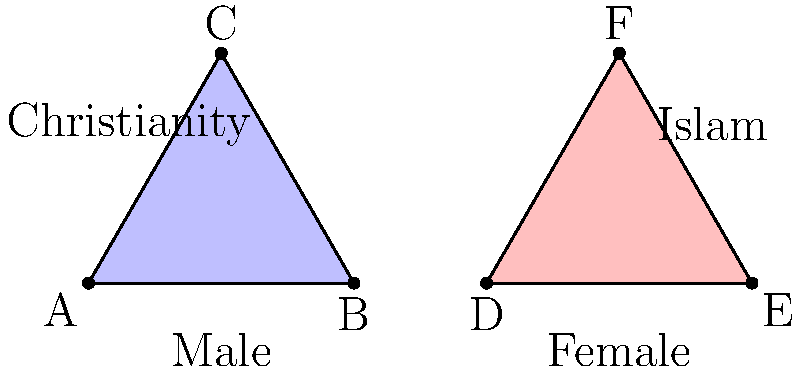In the diagram, two equilateral triangles represent the male and female populations in Christianity and Islam. If the area of each triangle is 12 square units, what is the area of the region where the triangles overlap, representing individuals who identify with both genders or faiths? To solve this problem, we need to follow these steps:

1) First, we need to calculate the side length of each equilateral triangle. The area of an equilateral triangle is given by the formula:

   $A = \frac{\sqrt{3}}{4}a^2$

   where $A$ is the area and $a$ is the side length.

2) We're given that $A = 12$, so:

   $12 = \frac{\sqrt{3}}{4}a^2$

3) Solving for $a$:

   $a^2 = \frac{48}{\sqrt{3}} = 16\sqrt{3}$
   $a = 4\sqrt[4]{3}$

4) The overlap region forms a rhombus. The area of a rhombus is given by the formula:

   $A_{rhombus} = \frac{d_1 \times d_2}{2}$

   where $d_1$ and $d_2$ are the diagonals of the rhombus.

5) In this case, one diagonal of the rhombus is equal to the side of the triangle, and the other is equal to the height of the triangle.

6) We already know one diagonal: $d_1 = 4\sqrt[4]{3}$

7) The height of an equilateral triangle is:

   $h = \frac{\sqrt{3}}{2}a = \frac{\sqrt{3}}{2} \times 4\sqrt[4]{3} = 2\sqrt{3}\sqrt[4]{3}$

8) So, the area of the rhombus is:

   $A_{rhombus} = \frac{4\sqrt[4]{3} \times 2\sqrt{3}\sqrt[4]{3}}{2} = 4\sqrt{3}\sqrt[3]{3}$

9) Simplifying:

   $A_{rhombus} = 4 \times 3^{\frac{5}{6}} = 4 \times 3^{\frac{1}{2}} \times 3^{\frac{1}{3}} = 4\sqrt{3}\sqrt[3]{3}$
Answer: $4\sqrt{3}\sqrt[3]{3}$ square units 